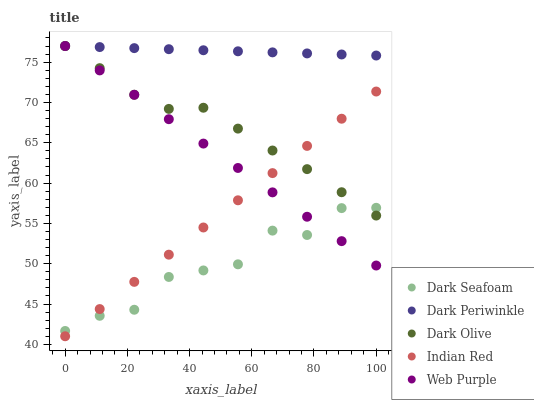Does Dark Seafoam have the minimum area under the curve?
Answer yes or no. Yes. Does Dark Periwinkle have the maximum area under the curve?
Answer yes or no. Yes. Does Dark Olive have the minimum area under the curve?
Answer yes or no. No. Does Dark Olive have the maximum area under the curve?
Answer yes or no. No. Is Dark Periwinkle the smoothest?
Answer yes or no. Yes. Is Dark Seafoam the roughest?
Answer yes or no. Yes. Is Dark Olive the smoothest?
Answer yes or no. No. Is Dark Olive the roughest?
Answer yes or no. No. Does Indian Red have the lowest value?
Answer yes or no. Yes. Does Dark Seafoam have the lowest value?
Answer yes or no. No. Does Dark Periwinkle have the highest value?
Answer yes or no. Yes. Does Dark Seafoam have the highest value?
Answer yes or no. No. Is Indian Red less than Dark Periwinkle?
Answer yes or no. Yes. Is Dark Periwinkle greater than Dark Seafoam?
Answer yes or no. Yes. Does Dark Periwinkle intersect Dark Olive?
Answer yes or no. Yes. Is Dark Periwinkle less than Dark Olive?
Answer yes or no. No. Is Dark Periwinkle greater than Dark Olive?
Answer yes or no. No. Does Indian Red intersect Dark Periwinkle?
Answer yes or no. No. 